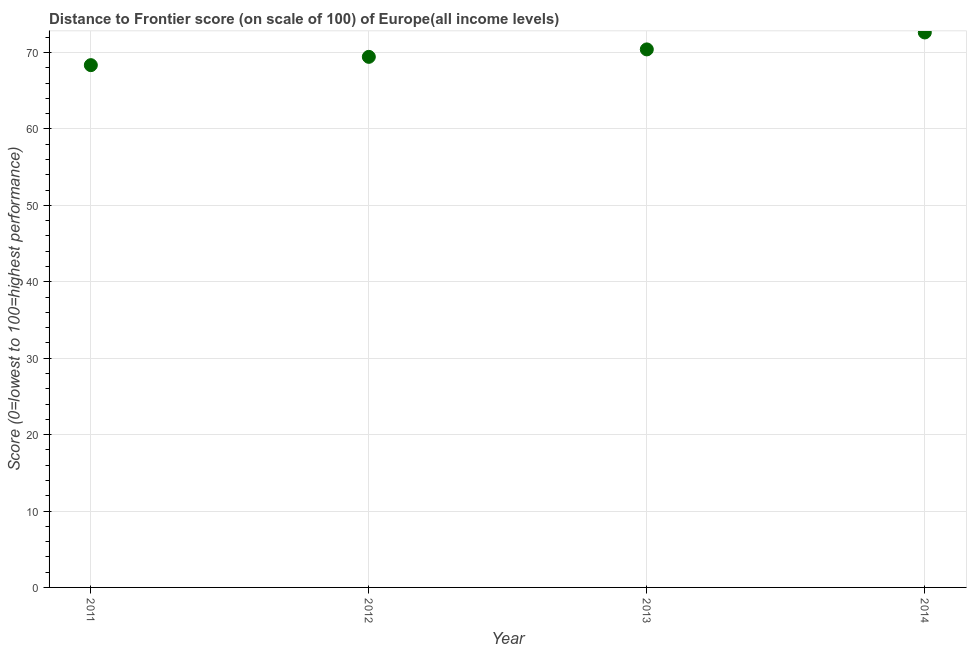What is the distance to frontier score in 2014?
Offer a terse response. 72.63. Across all years, what is the maximum distance to frontier score?
Keep it short and to the point. 72.63. Across all years, what is the minimum distance to frontier score?
Keep it short and to the point. 68.35. What is the sum of the distance to frontier score?
Your response must be concise. 280.82. What is the difference between the distance to frontier score in 2012 and 2014?
Make the answer very short. -3.19. What is the average distance to frontier score per year?
Make the answer very short. 70.2. What is the median distance to frontier score?
Offer a very short reply. 69.92. In how many years, is the distance to frontier score greater than 52 ?
Give a very brief answer. 4. What is the ratio of the distance to frontier score in 2012 to that in 2013?
Provide a short and direct response. 0.99. Is the difference between the distance to frontier score in 2011 and 2014 greater than the difference between any two years?
Ensure brevity in your answer.  Yes. What is the difference between the highest and the second highest distance to frontier score?
Offer a very short reply. 2.22. What is the difference between the highest and the lowest distance to frontier score?
Give a very brief answer. 4.28. How many dotlines are there?
Give a very brief answer. 1. What is the title of the graph?
Make the answer very short. Distance to Frontier score (on scale of 100) of Europe(all income levels). What is the label or title of the X-axis?
Provide a succinct answer. Year. What is the label or title of the Y-axis?
Give a very brief answer. Score (0=lowest to 100=highest performance). What is the Score (0=lowest to 100=highest performance) in 2011?
Offer a terse response. 68.35. What is the Score (0=lowest to 100=highest performance) in 2012?
Offer a very short reply. 69.43. What is the Score (0=lowest to 100=highest performance) in 2013?
Provide a short and direct response. 70.41. What is the Score (0=lowest to 100=highest performance) in 2014?
Offer a terse response. 72.63. What is the difference between the Score (0=lowest to 100=highest performance) in 2011 and 2012?
Keep it short and to the point. -1.09. What is the difference between the Score (0=lowest to 100=highest performance) in 2011 and 2013?
Ensure brevity in your answer.  -2.06. What is the difference between the Score (0=lowest to 100=highest performance) in 2011 and 2014?
Your answer should be compact. -4.28. What is the difference between the Score (0=lowest to 100=highest performance) in 2012 and 2013?
Your answer should be very brief. -0.97. What is the difference between the Score (0=lowest to 100=highest performance) in 2012 and 2014?
Your response must be concise. -3.19. What is the difference between the Score (0=lowest to 100=highest performance) in 2013 and 2014?
Offer a terse response. -2.22. What is the ratio of the Score (0=lowest to 100=highest performance) in 2011 to that in 2013?
Give a very brief answer. 0.97. What is the ratio of the Score (0=lowest to 100=highest performance) in 2011 to that in 2014?
Make the answer very short. 0.94. What is the ratio of the Score (0=lowest to 100=highest performance) in 2012 to that in 2013?
Keep it short and to the point. 0.99. What is the ratio of the Score (0=lowest to 100=highest performance) in 2012 to that in 2014?
Your answer should be very brief. 0.96. 